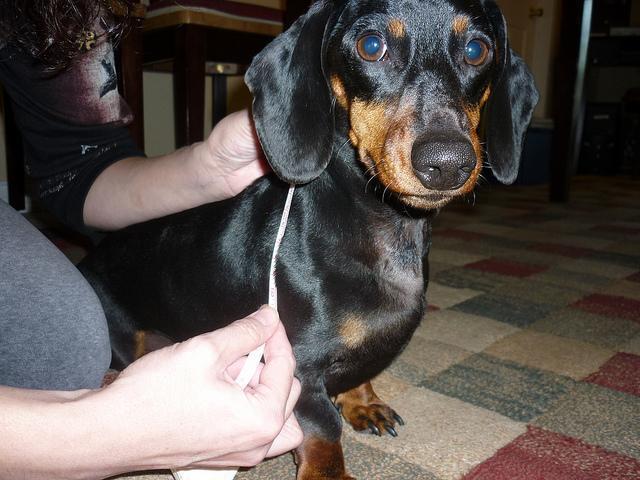How many bikes are in the street?
Give a very brief answer. 0. 